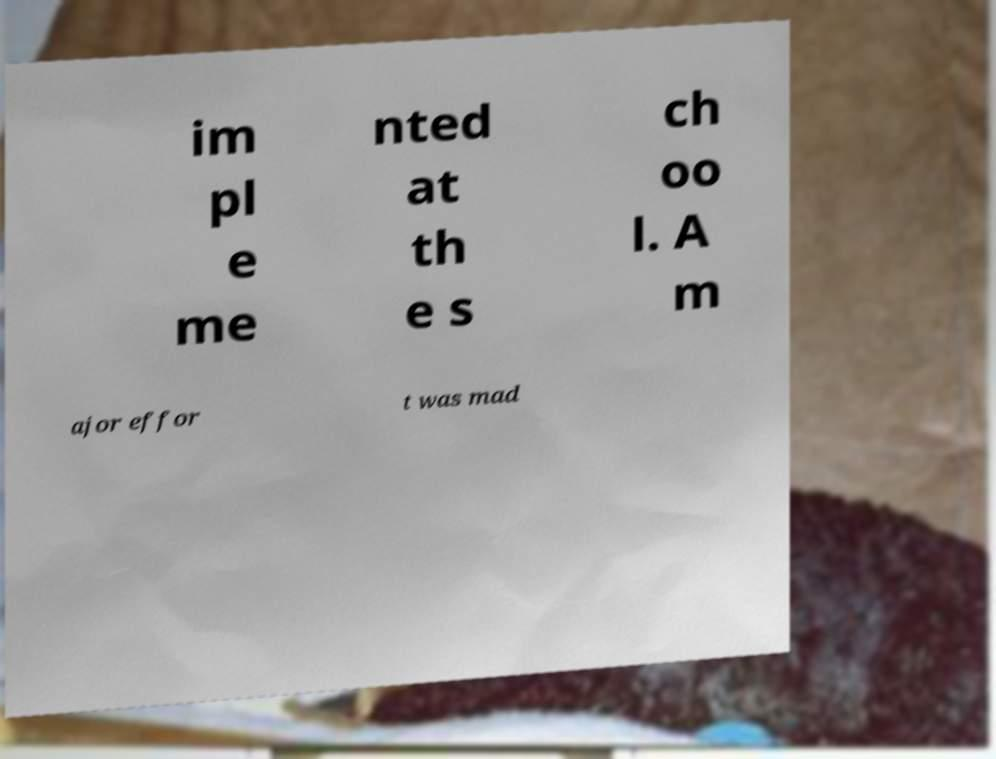Could you assist in decoding the text presented in this image and type it out clearly? im pl e me nted at th e s ch oo l. A m ajor effor t was mad 